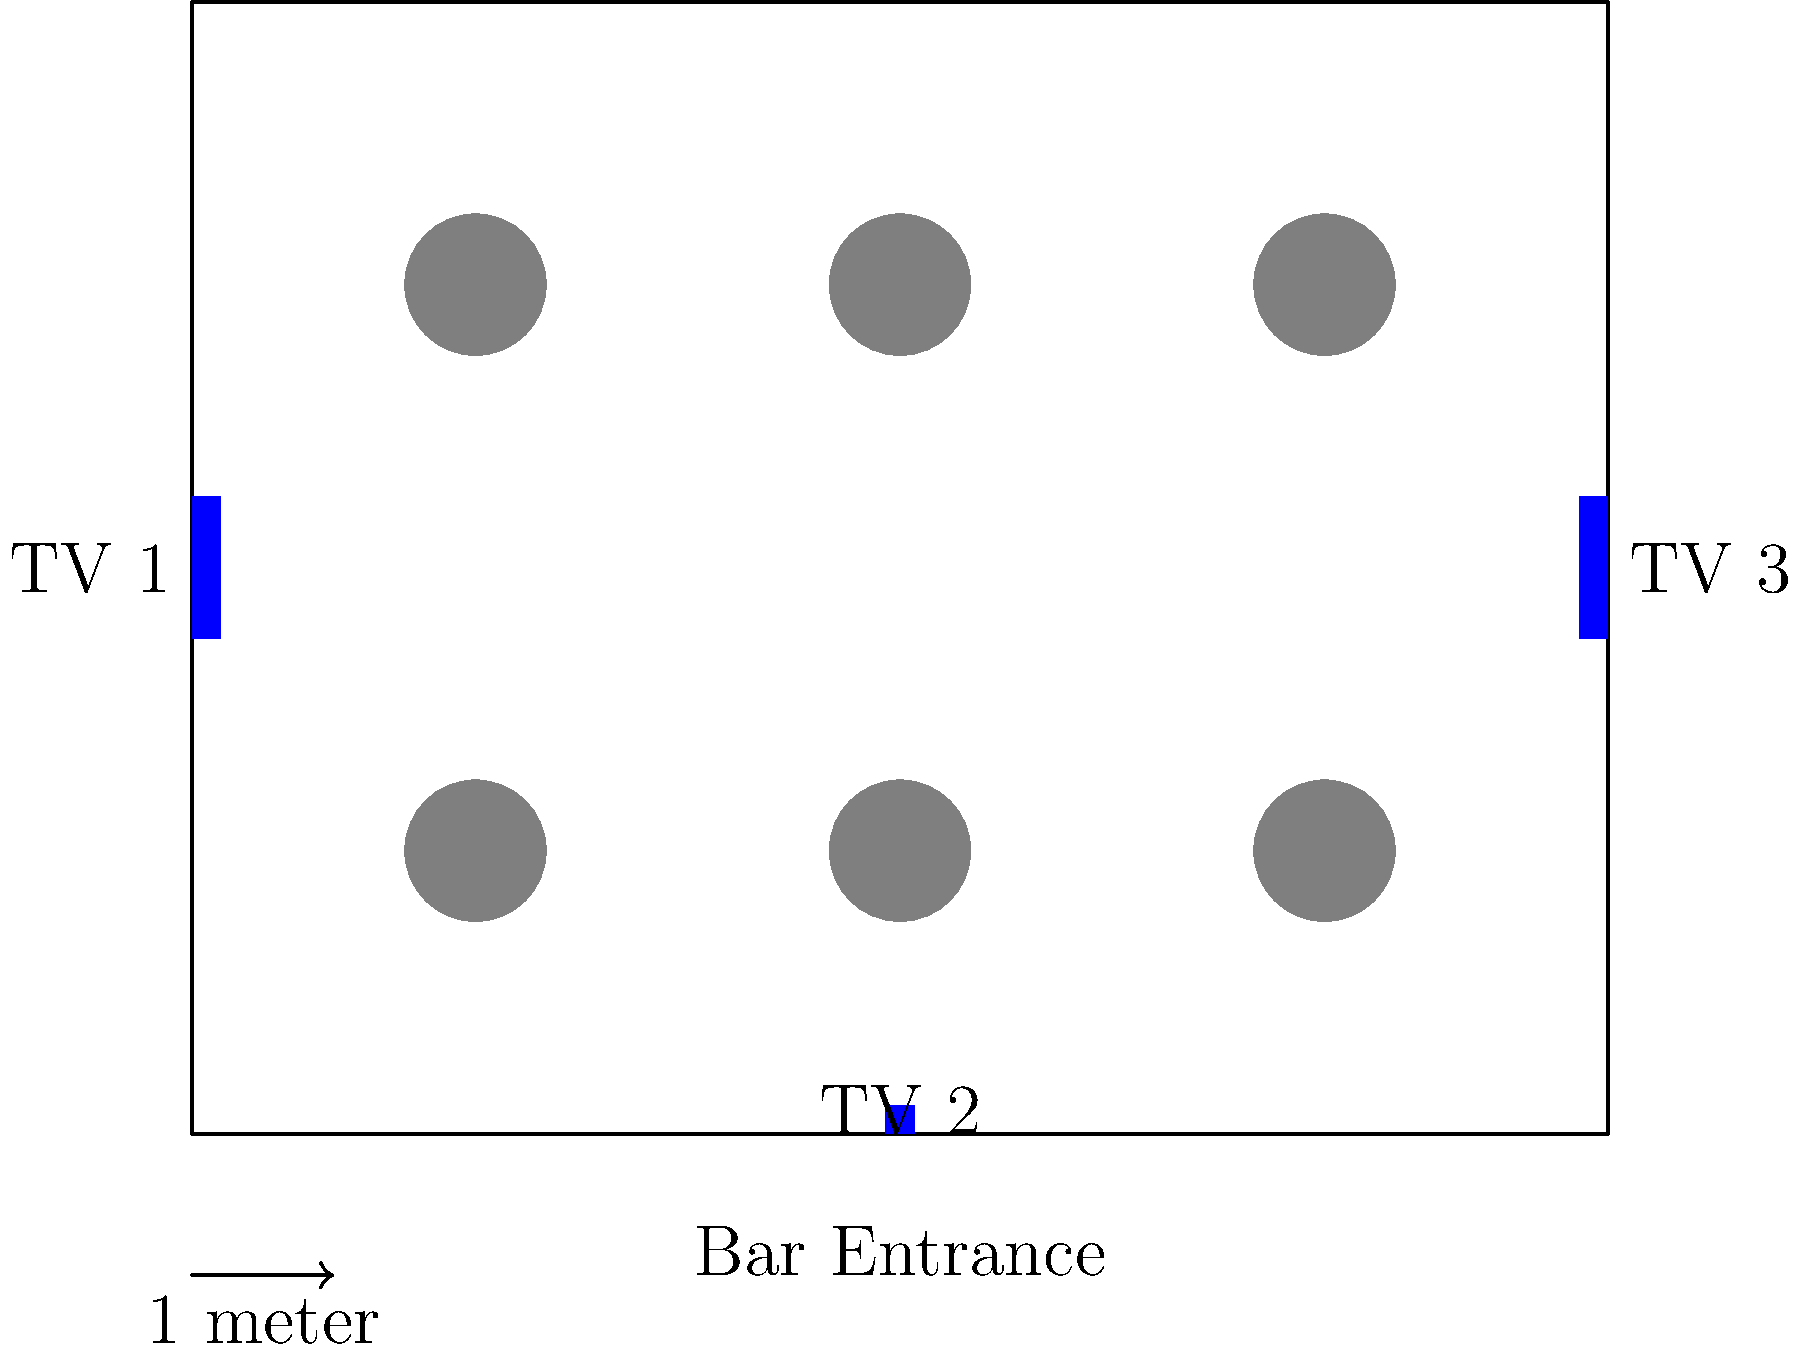Based on the floor plan of your sports bar shown above, which TV screen placement would be most effective for maximizing visibility during Chiefs game watch parties, and why? To determine the most effective TV screen placement, we need to consider several factors:

1. Coverage: Each TV should cover a different area of the bar to ensure all customers can view at least one screen.

2. Distance: TVs should be placed at optimal viewing distances from tables.

3. Angle: Screens should be positioned to minimize glare and provide comfortable viewing angles.

4. Obstruction: Ensure that no tables or other objects block the view of any TV.

Analyzing the current layout:

TV 1 (Left wall):
- Covers the left side of the bar
- Easily visible from tables 1 and 4
- May be difficult to view from tables 3 and 6

TV 2 (Bottom wall):
- Covers the bottom area of the bar
- Visible from tables 1, 2, and 3
- May be too low for comfortable viewing from back tables

TV 3 (Right wall):
- Covers the right side of the bar
- Easily visible from tables 3 and 6
- May be difficult to view from tables 1 and 4

The most effective placement would be:

1. Keep TV 1 and TV 3 in their current positions on opposite walls.
2. Move TV 2 to the top wall, centered (coordinates approximately (5,8)).

This arrangement would:
- Provide better coverage for all tables
- Improve viewing angles, especially for back tables
- Ensure each table has a clear view of at least two TVs
- Maximize visibility for all customers during game watch parties
Answer: Move TV 2 to the top wall, centered. 